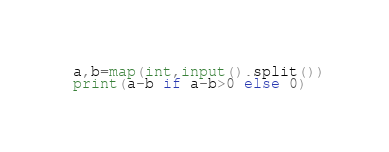<code> <loc_0><loc_0><loc_500><loc_500><_Python_>a,b=map(int,input().split())
print(a-b if a-b>0 else 0)</code> 